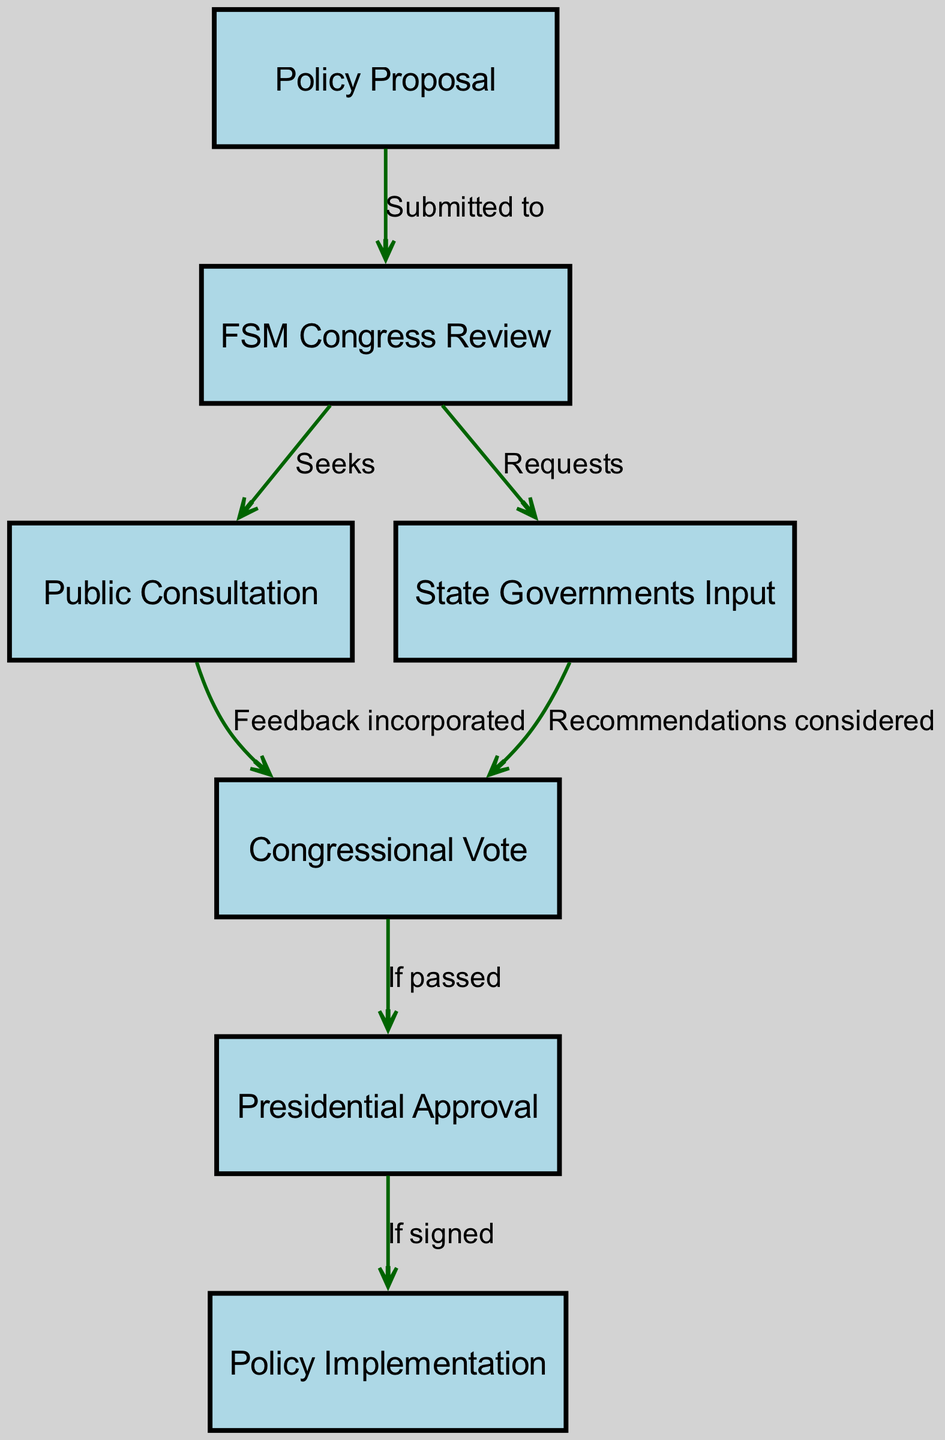What is the first step in the policy-making process? The first step in the flowchart is represented by the node labeled "Policy Proposal." This is the initial action required to start the policy-making process.
Answer: Policy Proposal How many nodes are present in the diagram? By counting the nodes listed, there are a total of 7 nodes included in the diagram.
Answer: 7 What type of feedback is incorporated after public consultation? After public consultation, feedback from the public is incorporated into the policy proposal according to the flow from the "Public Consultation" node to the "Congressional Vote" node.
Answer: Feedback Which node follows the "Congressional Vote" node? The node that follows the "Congressional Vote" is "Presidential Approval," as indicated by the directed edge from the former to the latter in the diagram.
Answer: Presidential Approval What action takes place if the Congressional Vote is passed? If the Congressional Vote is passed, the process moves to "Presidential Approval," indicating the next required step in the policy-making process.
Answer: Presidential Approval What input is sought from State Governments during the policy-making process? The flowchart indicates that the FSM Congress "Requests" input from the State Governments, demonstrating the involvement of the states in the review process.
Answer: Input What is the ultimate result of the policy-making process outlined in the diagram? The final result of the policy-making process, as shown in the last node of the flowchart, is "Policy Implementation." This indicates that the policy is put into practice following the necessary approvals.
Answer: Policy Implementation What kind of recommendations are considered after the input is received from State Governments? The diagram specifies that the recommendations provided by State Governments are considered when preparing for the Congressional Vote, indicating their influence on the decision-making process.
Answer: Recommendations What must happen for the policy to move to the "Policy Implementation" stage? The policy can only progress to the "Policy Implementation" stage if it has received 'Presidential Approval,' as specified by the directed edge from the approval node to the implementation node.
Answer: Presidential Approval 